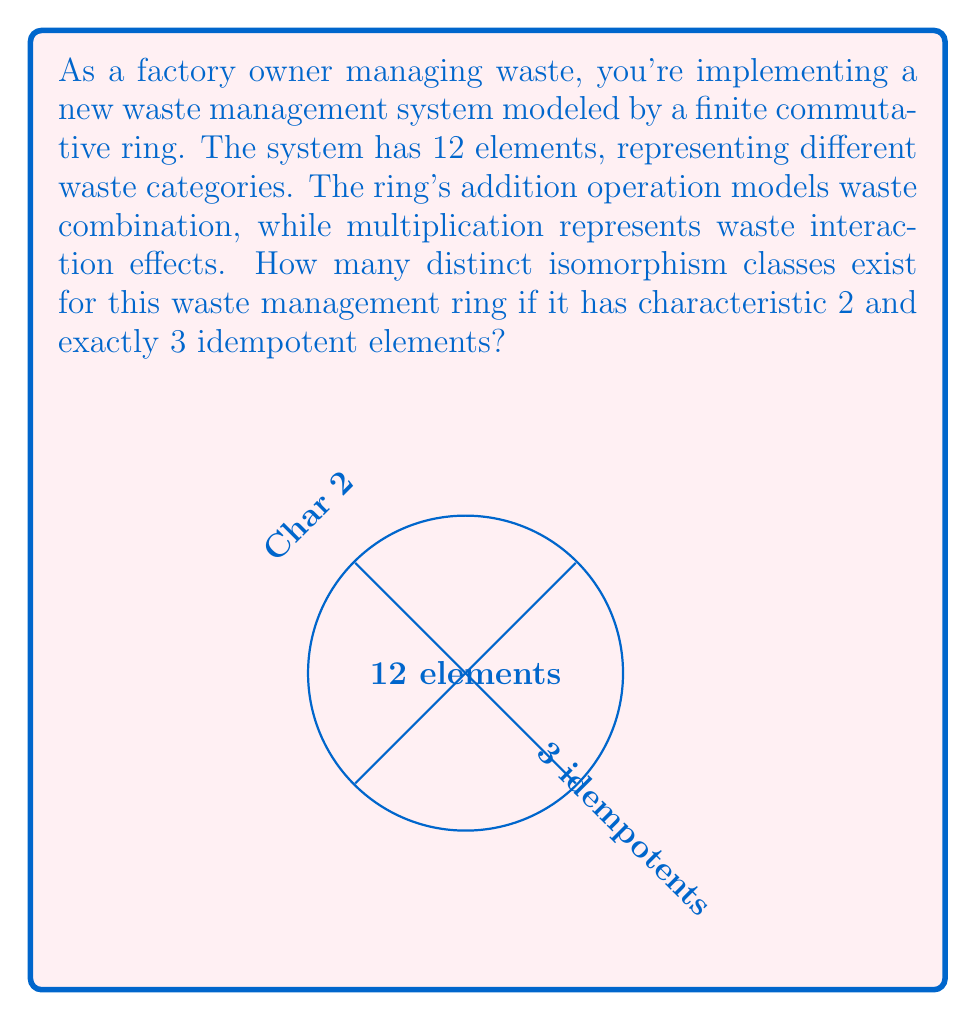Teach me how to tackle this problem. Let's approach this step-by-step:

1) First, recall that in a ring of characteristic 2, we have $1 + 1 = 0$.

2) The ring has 12 elements and characteristic 2, so it must be isomorphic to a direct product of rings of order $2^a$ and $3^b$ where $2^a \cdot 3^b = 12$. The only possibility is $a=2$ and $b=1$.

3) Thus, our ring is isomorphic to $R \cong \mathbb{F}_4 \times \mathbb{F}_3$, where $\mathbb{F}_4$ is the field with 4 elements and $\mathbb{F}_3$ is the field with 3 elements.

4) The idempotent elements in $R$ are of the form $(x,y)$ where $x$ is idempotent in $\mathbb{F}_4$ and $y$ is idempotent in $\mathbb{F}_3$.

5) $\mathbb{F}_4$ has 2 idempotents (0 and 1), and $\mathbb{F}_3$ has 2 idempotents (0 and 1).

6) Therefore, $R$ has $2 \cdot 2 = 4$ idempotents. However, we're given that $R$ has exactly 3 idempotents.

7) The only way to reconcile this is if $R \cong \mathbb{Z}_4 \times \mathbb{F}_3$, where $\mathbb{Z}_4$ is the ring of integers modulo 4.

8) $\mathbb{Z}_4$ has 2 idempotents (0 and 1), so $\mathbb{Z}_4 \times \mathbb{F}_3$ indeed has 3 idempotents: $(0,0)$, $(1,1)$, and $(0,1)$.

9) Since we've uniquely determined the structure of $R$, there is only one isomorphism class possible.
Answer: 1 